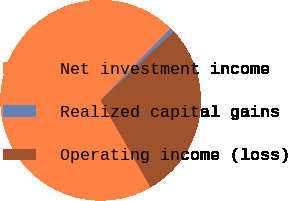Convert chart to OTSL. <chart><loc_0><loc_0><loc_500><loc_500><pie_chart><fcel>Net investment income<fcel>Realized capital gains<fcel>Operating income (loss)<nl><fcel>70.58%<fcel>0.73%<fcel>28.69%<nl></chart> 